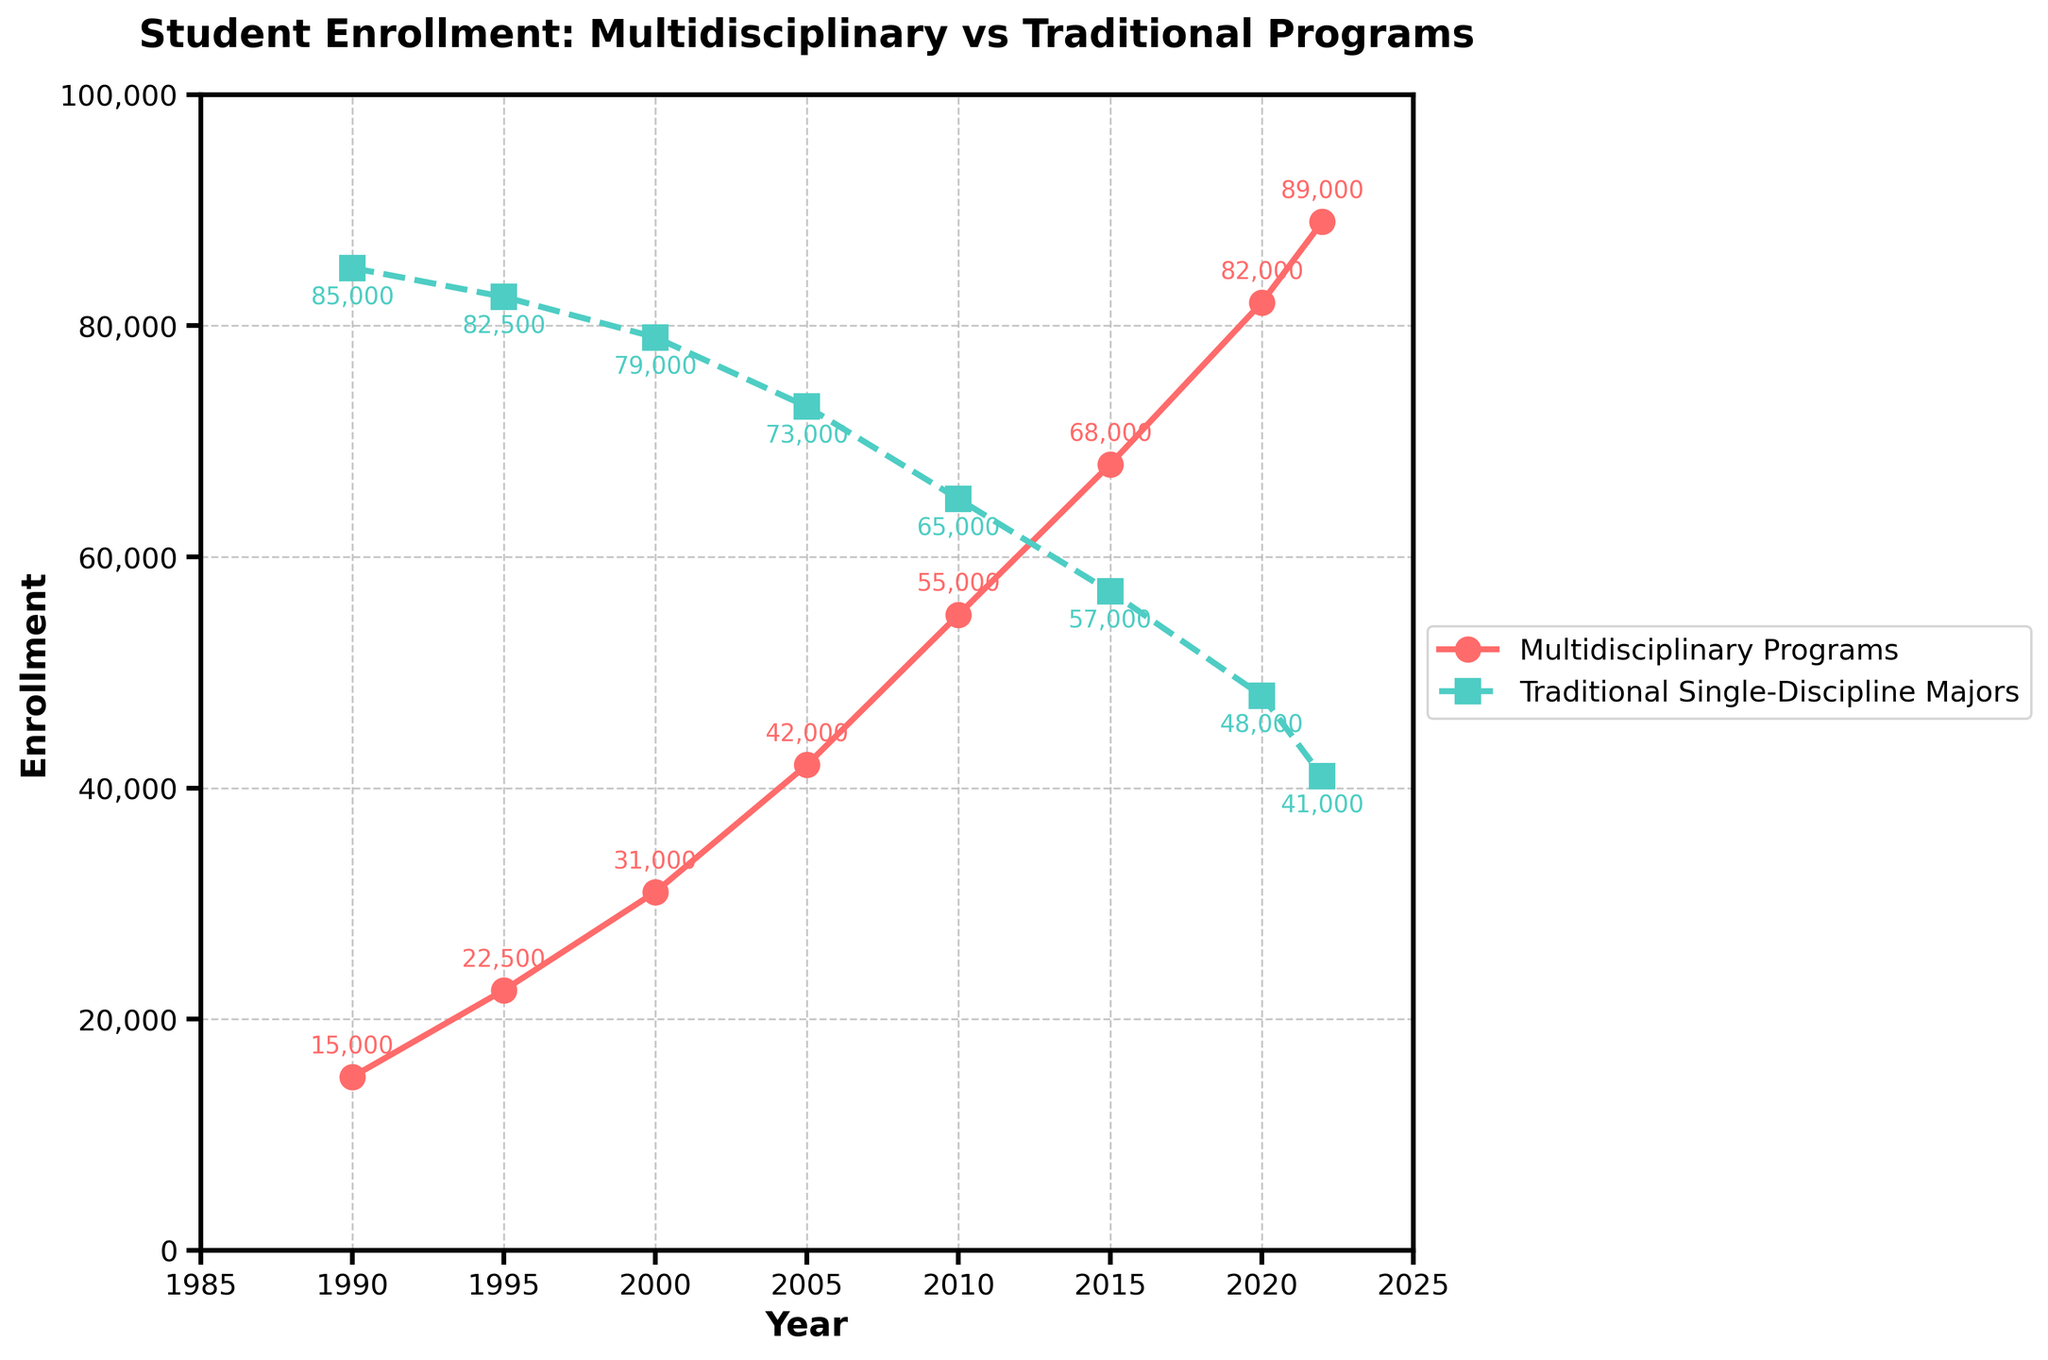what is the enrollment difference between Multidisciplinary Programs and Traditional Single-Discipline Majors in 2022? To find the difference, subtract the enrollment in Traditional Single-Discipline Majors from that in Multidisciplinary Programs for the year 2022: 89,000 - 41,000 = 48,000.
Answer: 48,000 Which program type saw a higher growth in enrollment from 1990 to 2022? Calculate the growth for both program types. For Multidisciplinary Programs, the increase is 89,000 - 15,000 = 74,000. For Traditional Single-Discipline Majors, the decrease is 85,000 - 41,000 = 44,000. Therefore, Multidisciplinary Programs saw higher growth.
Answer: Multidisciplinary Programs In what year did student enrollment in Multidisciplinary Programs surpass that of Traditional Single-Discipline Majors? Look at the plotted lines and identify when the red line (Multidisciplinary Programs) goes above the green line (Traditional Single-Discipline Majors). This occurs between 2015 and 2020. Checking the data: 2015 (68,000 < 57,000) and 2020 (82,000 > 48,000). Therefore, it must be 2020.
Answer: 2020 What is the average enrollment in Traditional Single-Discipline Majors from 1990 to 2022? Sum the enrollments from 1990 to 2022 and divide by the number of periods. (85,000 + 82,500 + 79,000 + 73,000 + 65,000 + 57,000 + 48,000 + 41,000) / 8 = 530,500 / 8 = 66,312.5
Answer: 66,312.5 Do both program types show a decreasing trend at any point within the time range? Examine the lines on the plot. The green line (Traditional Single-Discipline Majors) consistently decreases after 1990. The red line (Multidisciplinary Programs) consistently increases throughout the period. Thus, only Traditional Single-Discipline Majors show a decreasing trend.
Answer: No, only Traditional Single-Discipline Majors show a decreasing trend What is the compound annual growth rate (CAGR) for Multidisciplinary Programs from 1990 to 2022? Use the CAGR formula: CAGR = (Ending Value/Beginning Value)^(1/Number of Periods) - 1. With the values from the data: CAGR = (89,000 / 15,000)^(1/32) - 1 ≈ 0.0608 or 6.08%.
Answer: 6.08% How many more students were enrolled in Multidisciplinary Programs in 2010 compared to 2000? To find the increase, subtract the 2000 value from the 2010 value: 55,000 - 31,000 = 24,000.
Answer: 24,000 Which year had the highest enrollment for Traditional Single-Discipline Majors? According to the plot, the highest point for Traditional Single-Discipline Majors (green line) is at the start of the time range, in 1990, with 85,000 enrollments.
Answer: 1990 